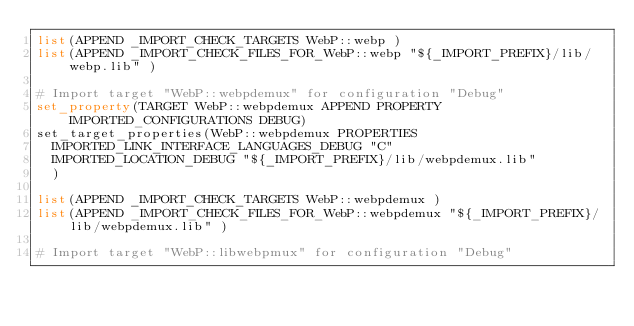Convert code to text. <code><loc_0><loc_0><loc_500><loc_500><_CMake_>list(APPEND _IMPORT_CHECK_TARGETS WebP::webp )
list(APPEND _IMPORT_CHECK_FILES_FOR_WebP::webp "${_IMPORT_PREFIX}/lib/webp.lib" )

# Import target "WebP::webpdemux" for configuration "Debug"
set_property(TARGET WebP::webpdemux APPEND PROPERTY IMPORTED_CONFIGURATIONS DEBUG)
set_target_properties(WebP::webpdemux PROPERTIES
  IMPORTED_LINK_INTERFACE_LANGUAGES_DEBUG "C"
  IMPORTED_LOCATION_DEBUG "${_IMPORT_PREFIX}/lib/webpdemux.lib"
  )

list(APPEND _IMPORT_CHECK_TARGETS WebP::webpdemux )
list(APPEND _IMPORT_CHECK_FILES_FOR_WebP::webpdemux "${_IMPORT_PREFIX}/lib/webpdemux.lib" )

# Import target "WebP::libwebpmux" for configuration "Debug"</code> 